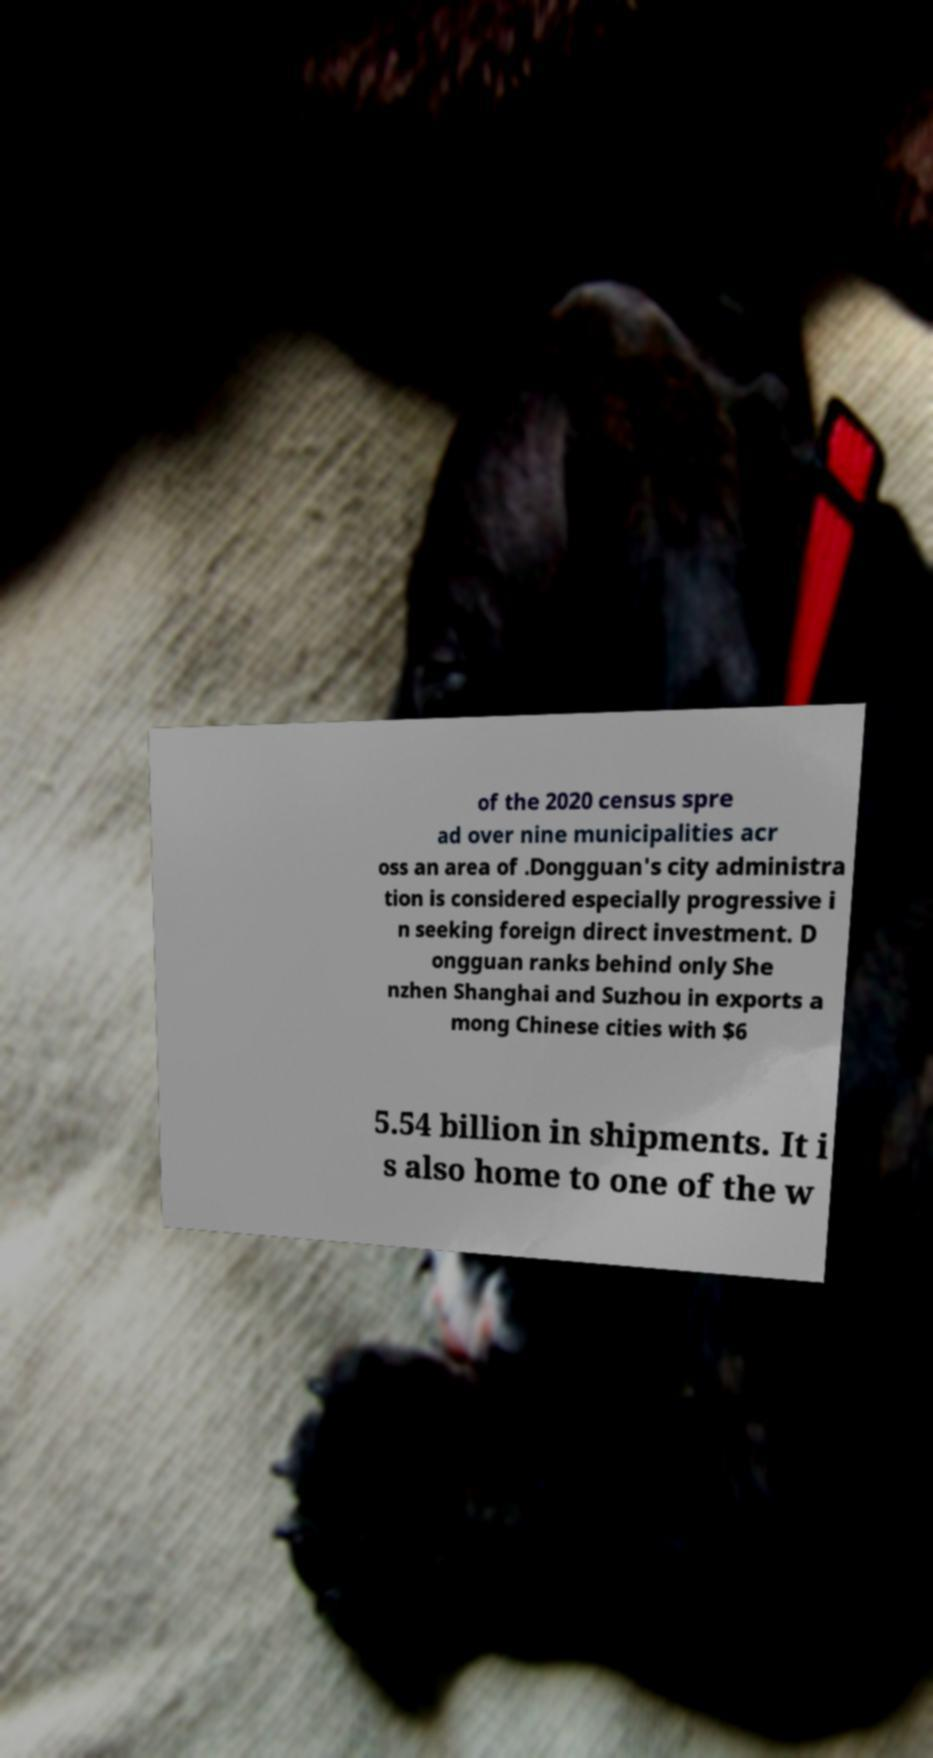Please identify and transcribe the text found in this image. of the 2020 census spre ad over nine municipalities acr oss an area of .Dongguan's city administra tion is considered especially progressive i n seeking foreign direct investment. D ongguan ranks behind only She nzhen Shanghai and Suzhou in exports a mong Chinese cities with $6 5.54 billion in shipments. It i s also home to one of the w 